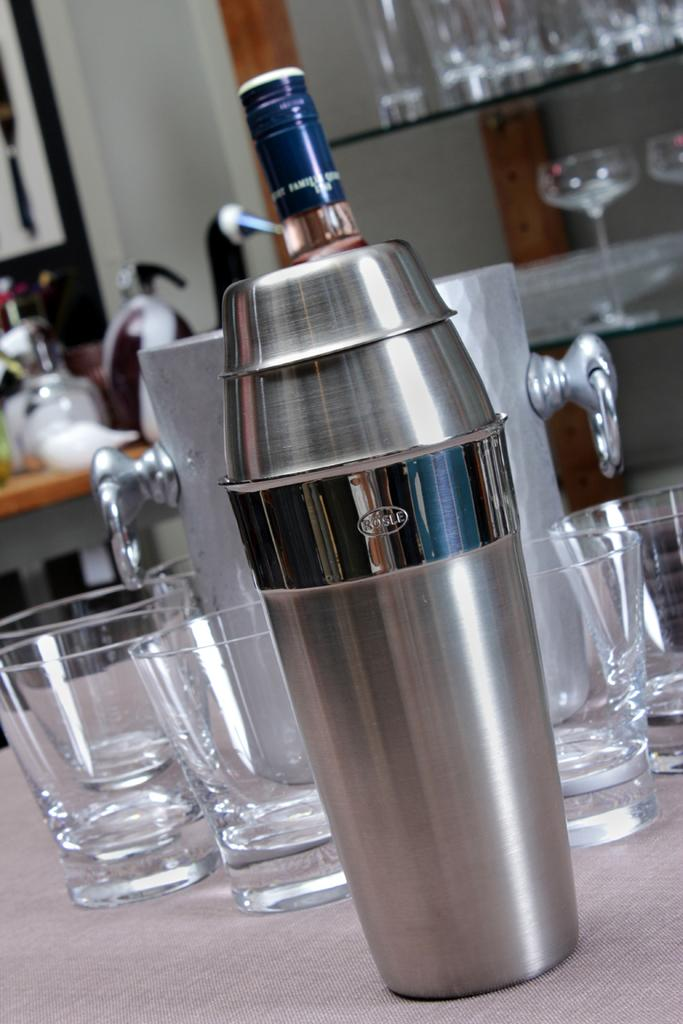What objects are present in the image that can be used for drinking? There are glasses in the image that can be used for drinking. What is the other object in the image that is related to drinking? There is a bottle in the image. What type of canvas is visible in the image? There is no canvas present in the image. Is the quicksand visible in the image? There is no quicksand present in the image. 